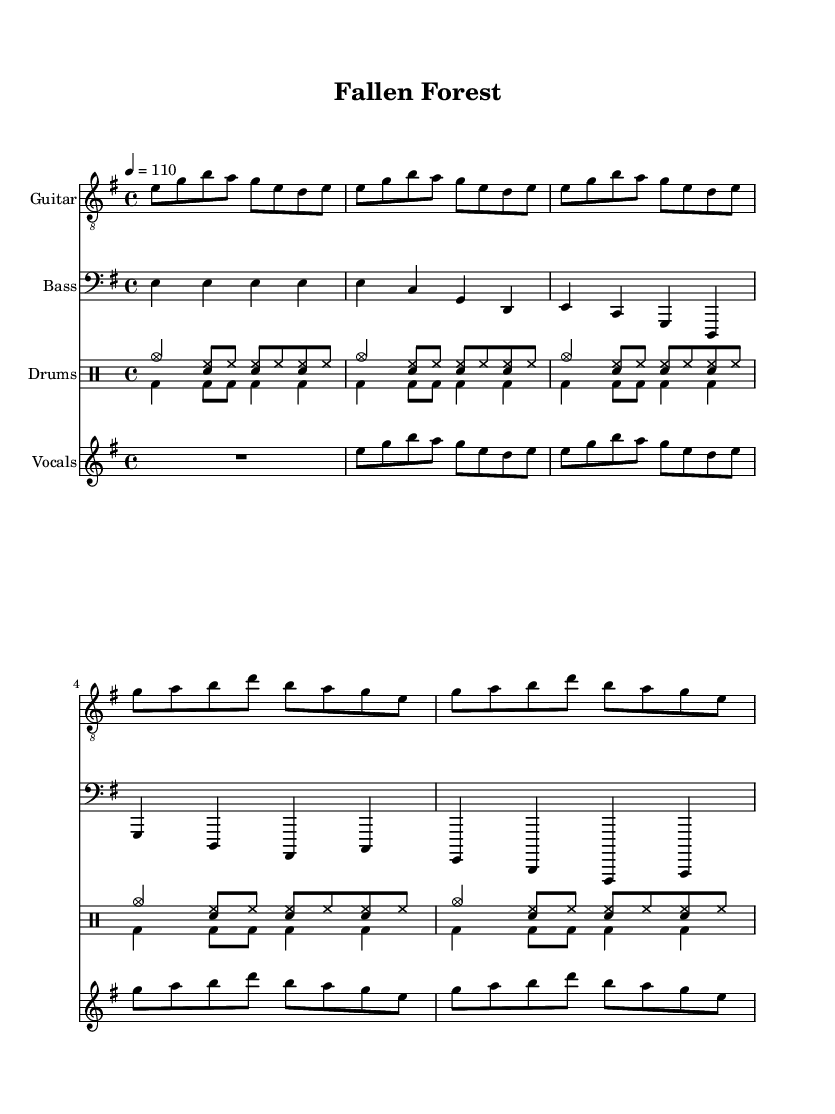What is the key signature of this music? The key signature is E minor, which has one sharp (F#). This can be determined by looking at the key signature at the beginning of the sheet music.
Answer: E minor What is the time signature of this music? The time signature is 4/4, indicated by the notation found at the beginning of the sheet music. This means there are four beats per measure.
Answer: 4/4 What is the tempo marking for this piece? The tempo marking is 110 beats per minute, indicated by the tempo text "4 = 110" in the global section of the code. This informs the performer how fast the piece should be played.
Answer: 110 How many measures are there in the chorus section? The chorus section consists of 4 measures, which can be counted by observing the rhythmic patterns set over the musical notes during the chorus part.
Answer: 4 measures What emotional theme does the lyrics suggest? The lyrics suggest a theme of loss and suffering due to deforestation and habitat destruction, as indicated by phrases like "Fallen forest, lost habitat" in the chorus. This suggests a poignant commentary on environmental degradation.
Answer: Loss and suffering What instruments are used in this track? The instruments listed include guitar, bass, drums, and vocals, as shown by the headers for each staff in the score section of the code. This reflects a common arrangement in rock music, specifically grunge.
Answer: Guitar, bass, drums, vocals 